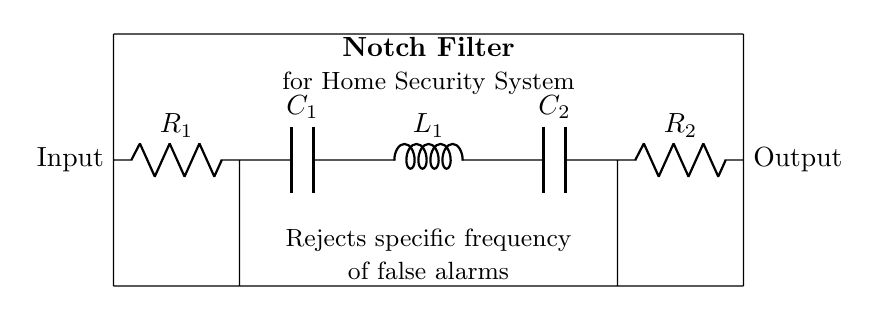What components are used in the notch filter? The components include two resistors (R1, R2), two capacitors (C1, C2), and one inductor (L1). Each component is labeled in the circuit diagram.
Answer: Resistors, capacitors, inductor What is the function of the notch filter in this circuit? The notch filter is designed to reject a specific frequency of false alarms, allowing other signals to pass through without interference. This is crucial for home security systems to filter out unwanted noise.
Answer: Reject specific frequency How many capacitors are present in the circuit? The diagram clearly shows two capacitors, C1 and C2, which are essential for the filtering function of the notch filter.
Answer: Two capacitors What is the input of the notch filter? The input of the notch filter is indicated on the left side of the diagram, where the signal enters the circuit. It is labeled as "Input."
Answer: Input What is connected to the output of the notch filter? The output, located on the right side of the circuit, is where the filtered signal exits after processing by the filter. It is labeled as "Output."
Answer: Output What type of filter is this circuit implementing? This circuit specifically implements a notch filter, which is a type of band-stop filter that eliminates a narrow band of frequencies while allowing others to pass. This is revealed in the labeling on the diagram.
Answer: Notch filter 